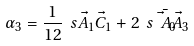<formula> <loc_0><loc_0><loc_500><loc_500>\alpha _ { 3 } = \frac { 1 } { 1 2 } \ s { \vec { A } _ { 1 } } { \vec { C } _ { 1 } } + 2 \ s { \bar { \vec { A } _ { 0 } } } { \vec { A } _ { 3 } }</formula> 